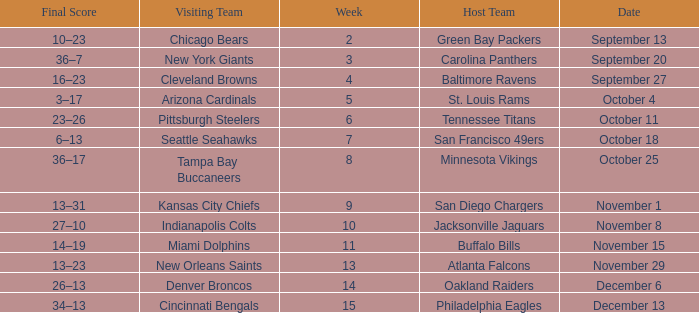When did the Baltimore Ravens play at home ? September 27. 